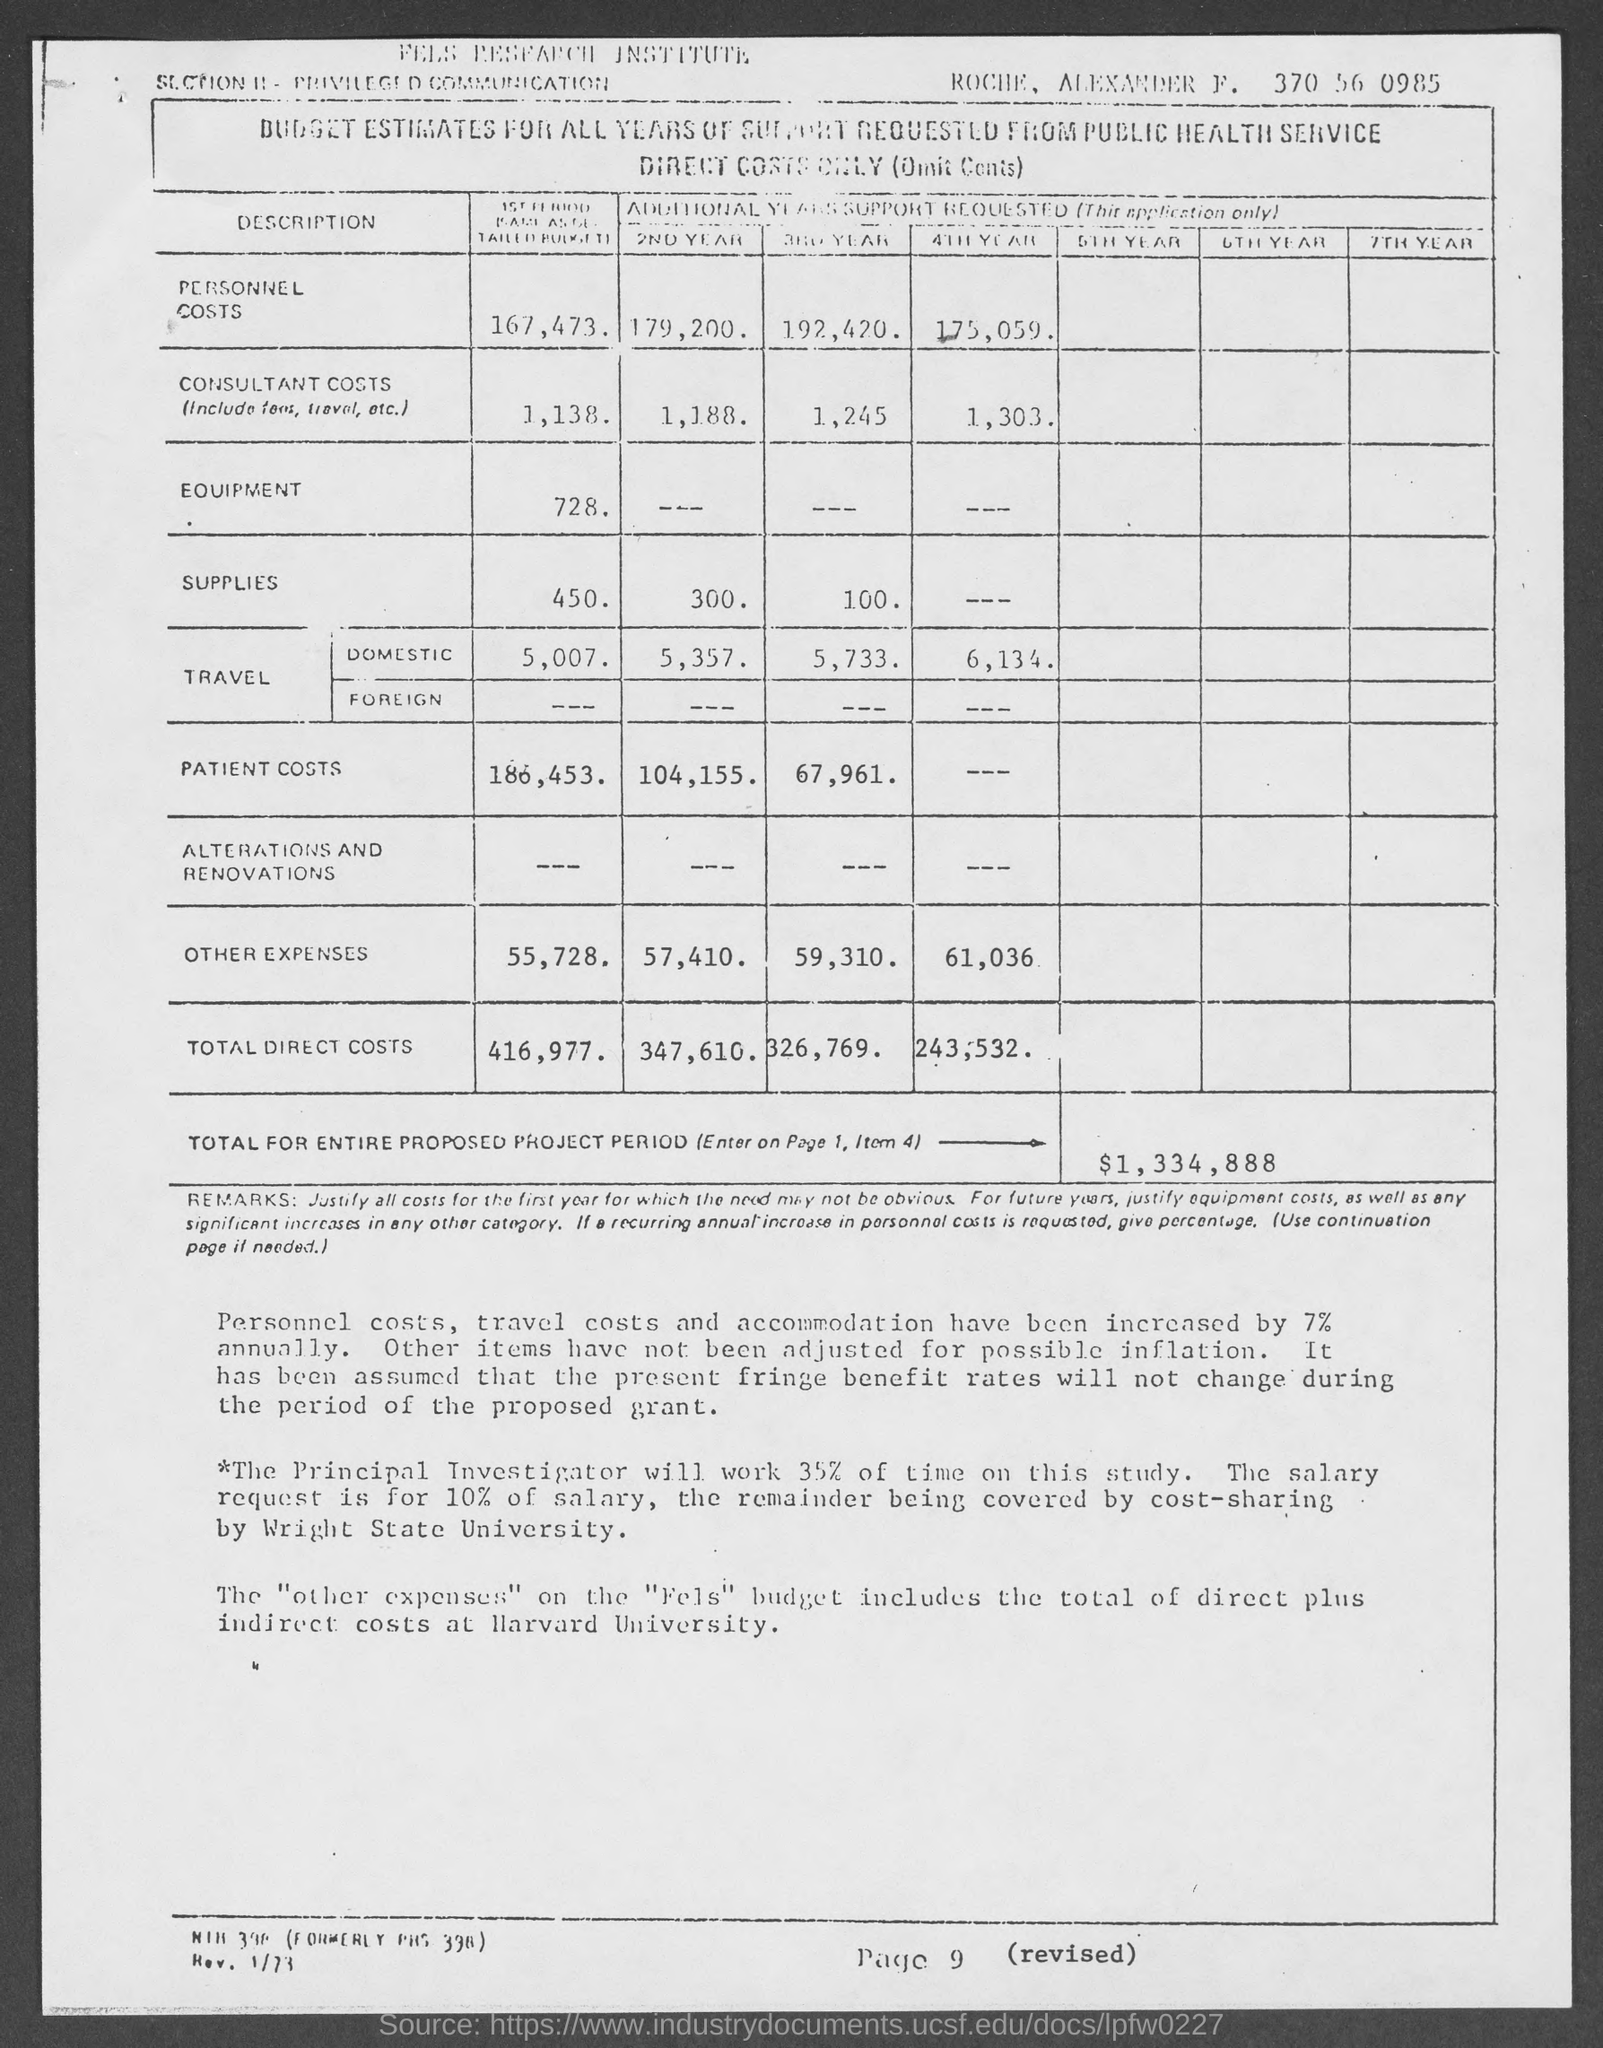What is the page no. at bottom of the page?
Ensure brevity in your answer.  Page 9. What is the total amount for entire proposed project period?
Your answer should be compact. $1,334,888. 